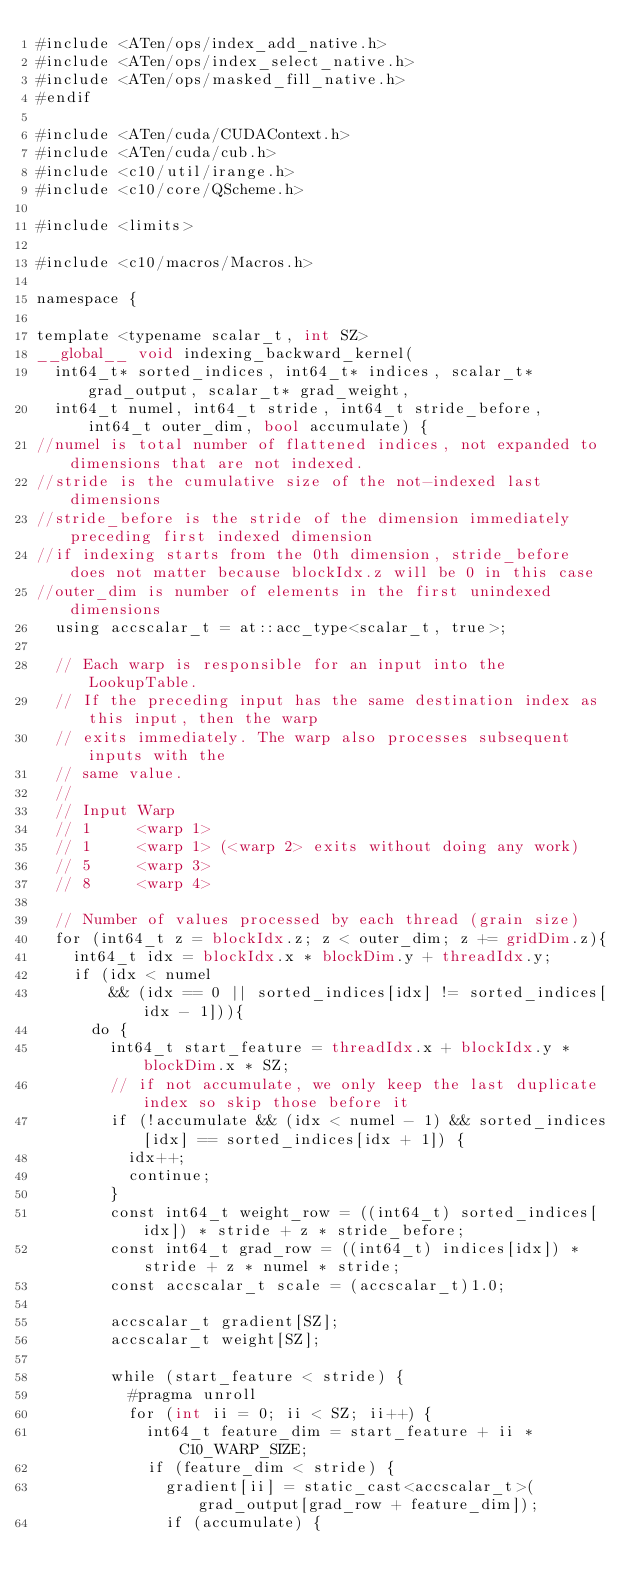<code> <loc_0><loc_0><loc_500><loc_500><_Cuda_>#include <ATen/ops/index_add_native.h>
#include <ATen/ops/index_select_native.h>
#include <ATen/ops/masked_fill_native.h>
#endif

#include <ATen/cuda/CUDAContext.h>
#include <ATen/cuda/cub.h>
#include <c10/util/irange.h>
#include <c10/core/QScheme.h>

#include <limits>

#include <c10/macros/Macros.h>

namespace {

template <typename scalar_t, int SZ>
__global__ void indexing_backward_kernel(
  int64_t* sorted_indices, int64_t* indices, scalar_t* grad_output, scalar_t* grad_weight,
  int64_t numel, int64_t stride, int64_t stride_before, int64_t outer_dim, bool accumulate) {
//numel is total number of flattened indices, not expanded to dimensions that are not indexed.
//stride is the cumulative size of the not-indexed last dimensions
//stride_before is the stride of the dimension immediately preceding first indexed dimension
//if indexing starts from the 0th dimension, stride_before does not matter because blockIdx.z will be 0 in this case
//outer_dim is number of elements in the first unindexed dimensions
  using accscalar_t = at::acc_type<scalar_t, true>;

  // Each warp is responsible for an input into the LookupTable.
  // If the preceding input has the same destination index as this input, then the warp
  // exits immediately. The warp also processes subsequent inputs with the
  // same value.
  //
  // Input Warp
  // 1     <warp 1>
  // 1     <warp 1> (<warp 2> exits without doing any work)
  // 5     <warp 3>
  // 8     <warp 4>

  // Number of values processed by each thread (grain size)
  for (int64_t z = blockIdx.z; z < outer_dim; z += gridDim.z){
    int64_t idx = blockIdx.x * blockDim.y + threadIdx.y;
    if (idx < numel
        && (idx == 0 || sorted_indices[idx] != sorted_indices[idx - 1])){
      do {
        int64_t start_feature = threadIdx.x + blockIdx.y * blockDim.x * SZ;
        // if not accumulate, we only keep the last duplicate index so skip those before it
        if (!accumulate && (idx < numel - 1) && sorted_indices[idx] == sorted_indices[idx + 1]) {
          idx++;
          continue;
        }
        const int64_t weight_row = ((int64_t) sorted_indices[idx]) * stride + z * stride_before;
        const int64_t grad_row = ((int64_t) indices[idx]) * stride + z * numel * stride;
        const accscalar_t scale = (accscalar_t)1.0;

        accscalar_t gradient[SZ];
        accscalar_t weight[SZ];

        while (start_feature < stride) {
          #pragma unroll
          for (int ii = 0; ii < SZ; ii++) {
            int64_t feature_dim = start_feature + ii * C10_WARP_SIZE;
            if (feature_dim < stride) {
              gradient[ii] = static_cast<accscalar_t>(grad_output[grad_row + feature_dim]);
              if (accumulate) {</code> 